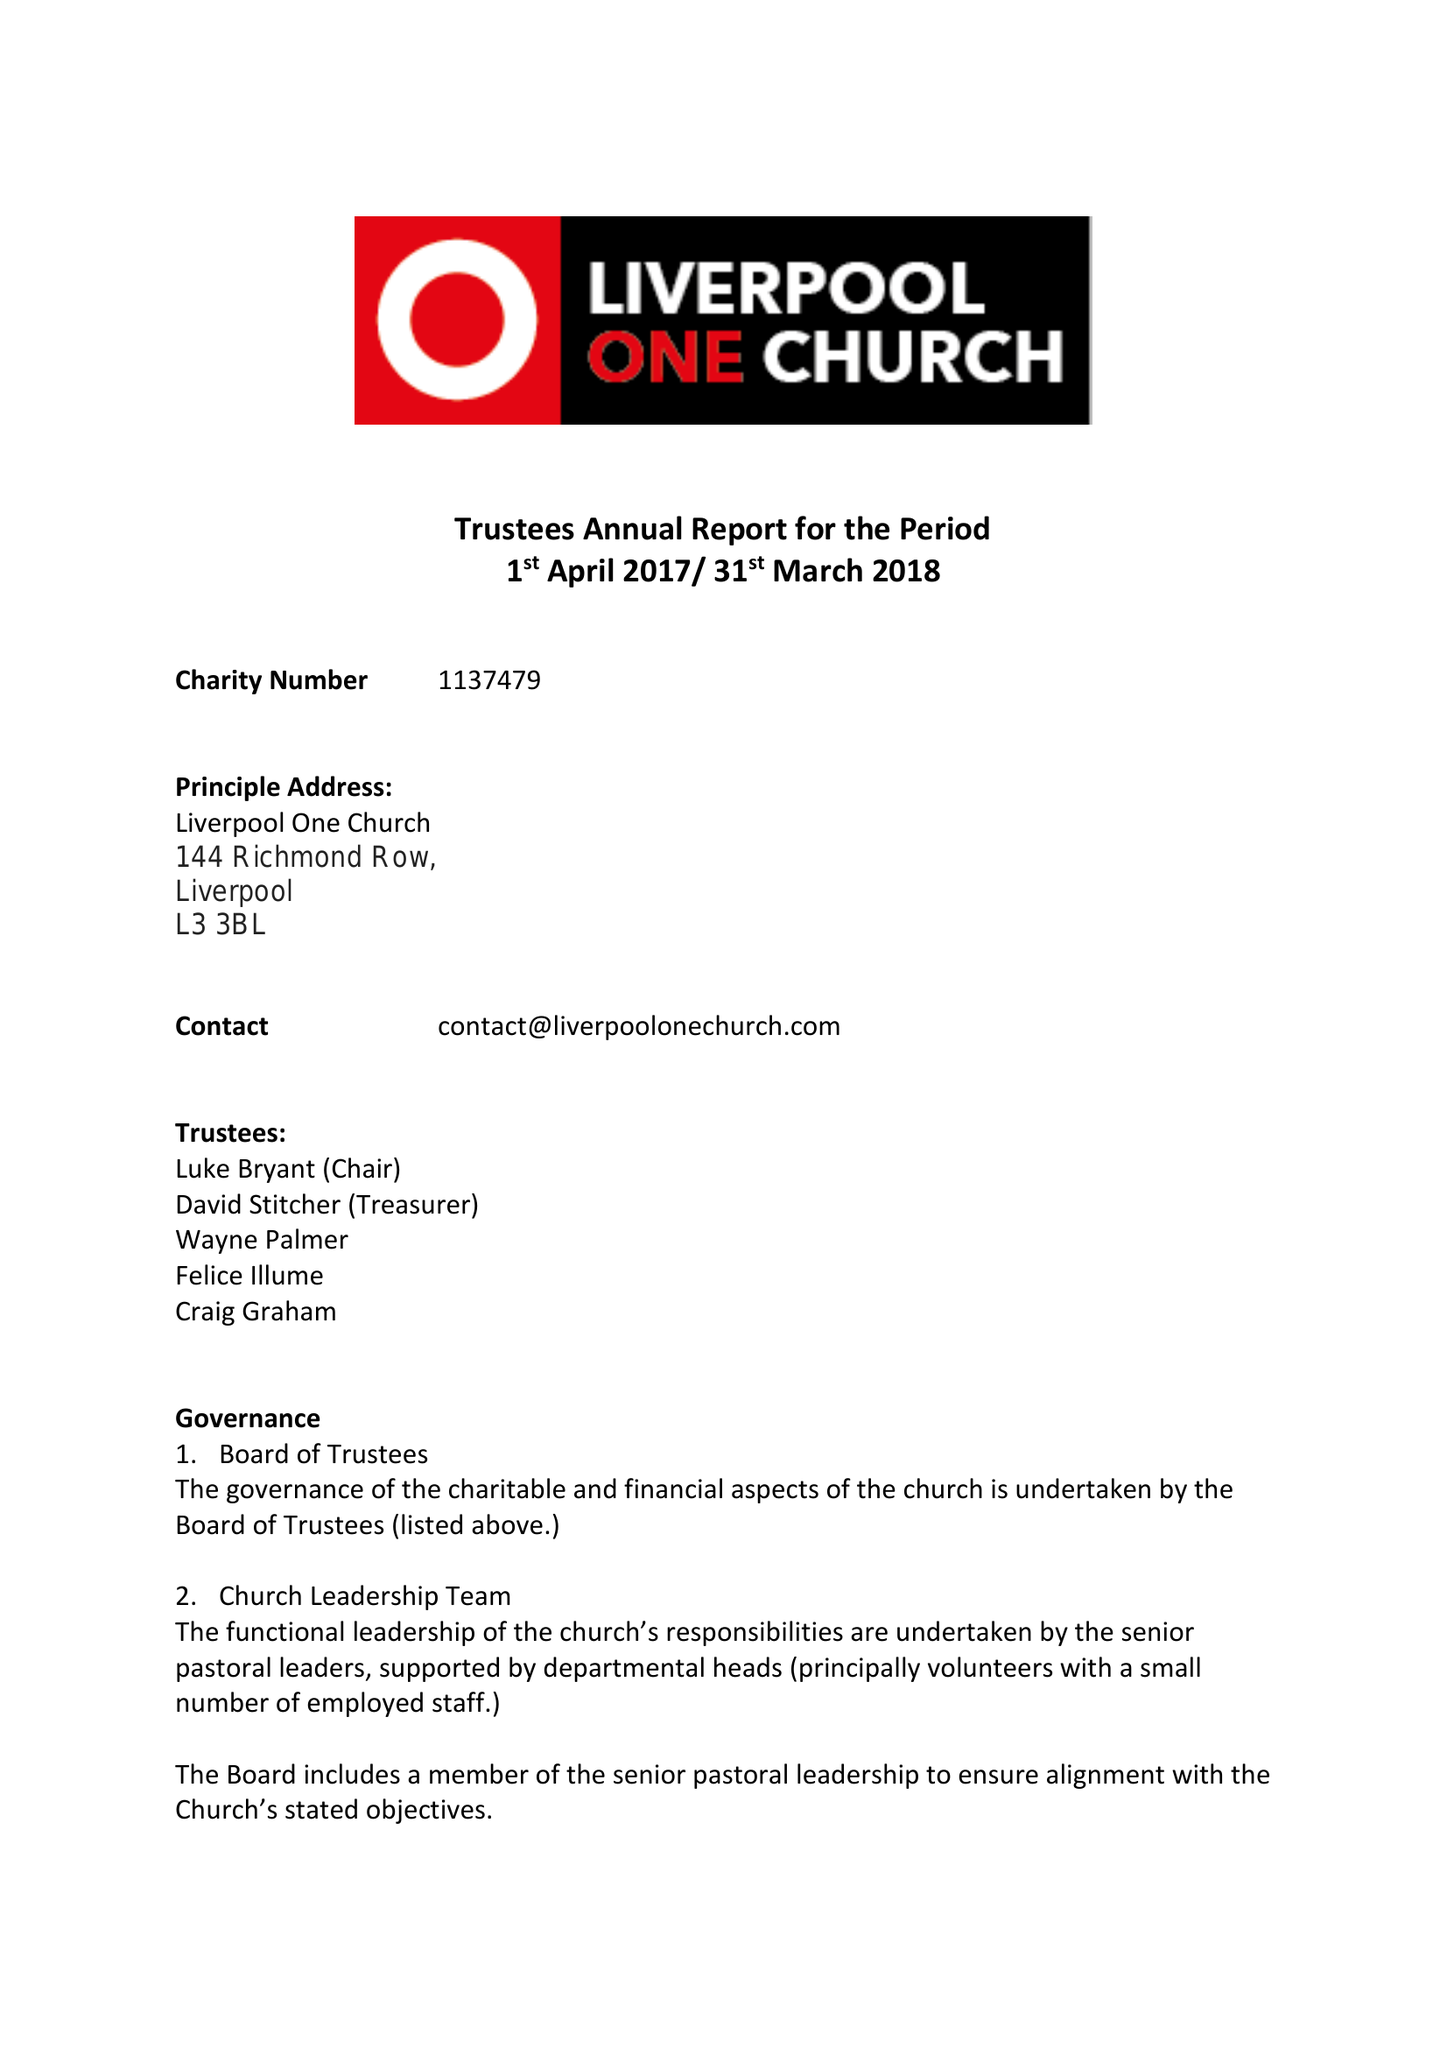What is the value for the charity_name?
Answer the question using a single word or phrase. Liverpool One Church 